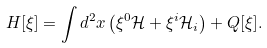<formula> <loc_0><loc_0><loc_500><loc_500>H [ \xi ] = \int d ^ { 2 } x \left ( { \xi } ^ { 0 } \mathcal { H } + { \xi } ^ { i } \mathcal { H } _ { i } \right ) + Q [ \xi ] .</formula> 